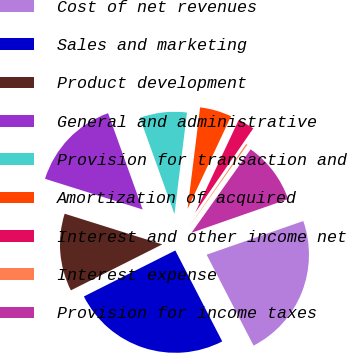<chart> <loc_0><loc_0><loc_500><loc_500><pie_chart><fcel>Cost of net revenues<fcel>Sales and marketing<fcel>Product development<fcel>General and administrative<fcel>Provision for transaction and<fcel>Amortization of acquired<fcel>Interest and other income net<fcel>Interest expense<fcel>Provision for income taxes<nl><fcel>22.75%<fcel>25.16%<fcel>12.26%<fcel>14.67%<fcel>7.44%<fcel>5.03%<fcel>2.62%<fcel>0.21%<fcel>9.85%<nl></chart> 